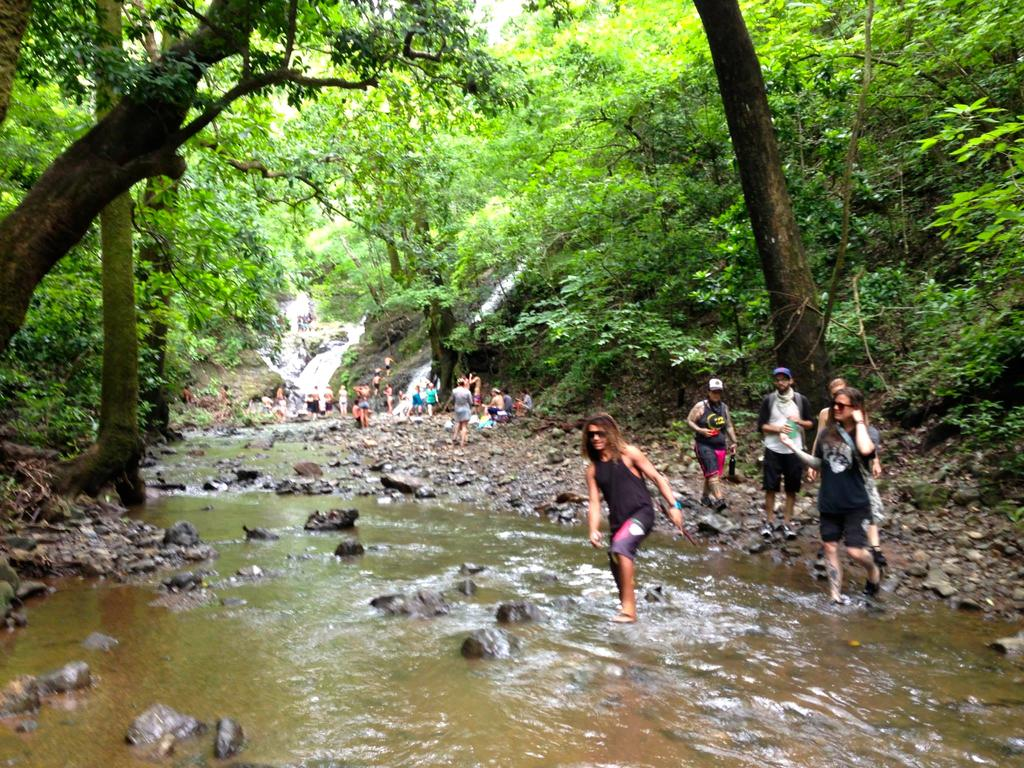What is the primary element present in the image? There is water in the image. What other objects or features can be seen in the image? There are stones, trees, and people in the image. Can you describe the attire of some people in the image? Some people are wearing caps and shades in the image. Where is the office located in the image? There is no office present in the image. Can you describe the people jumping into the water in the image? There are no people jumping into the water in the image. 